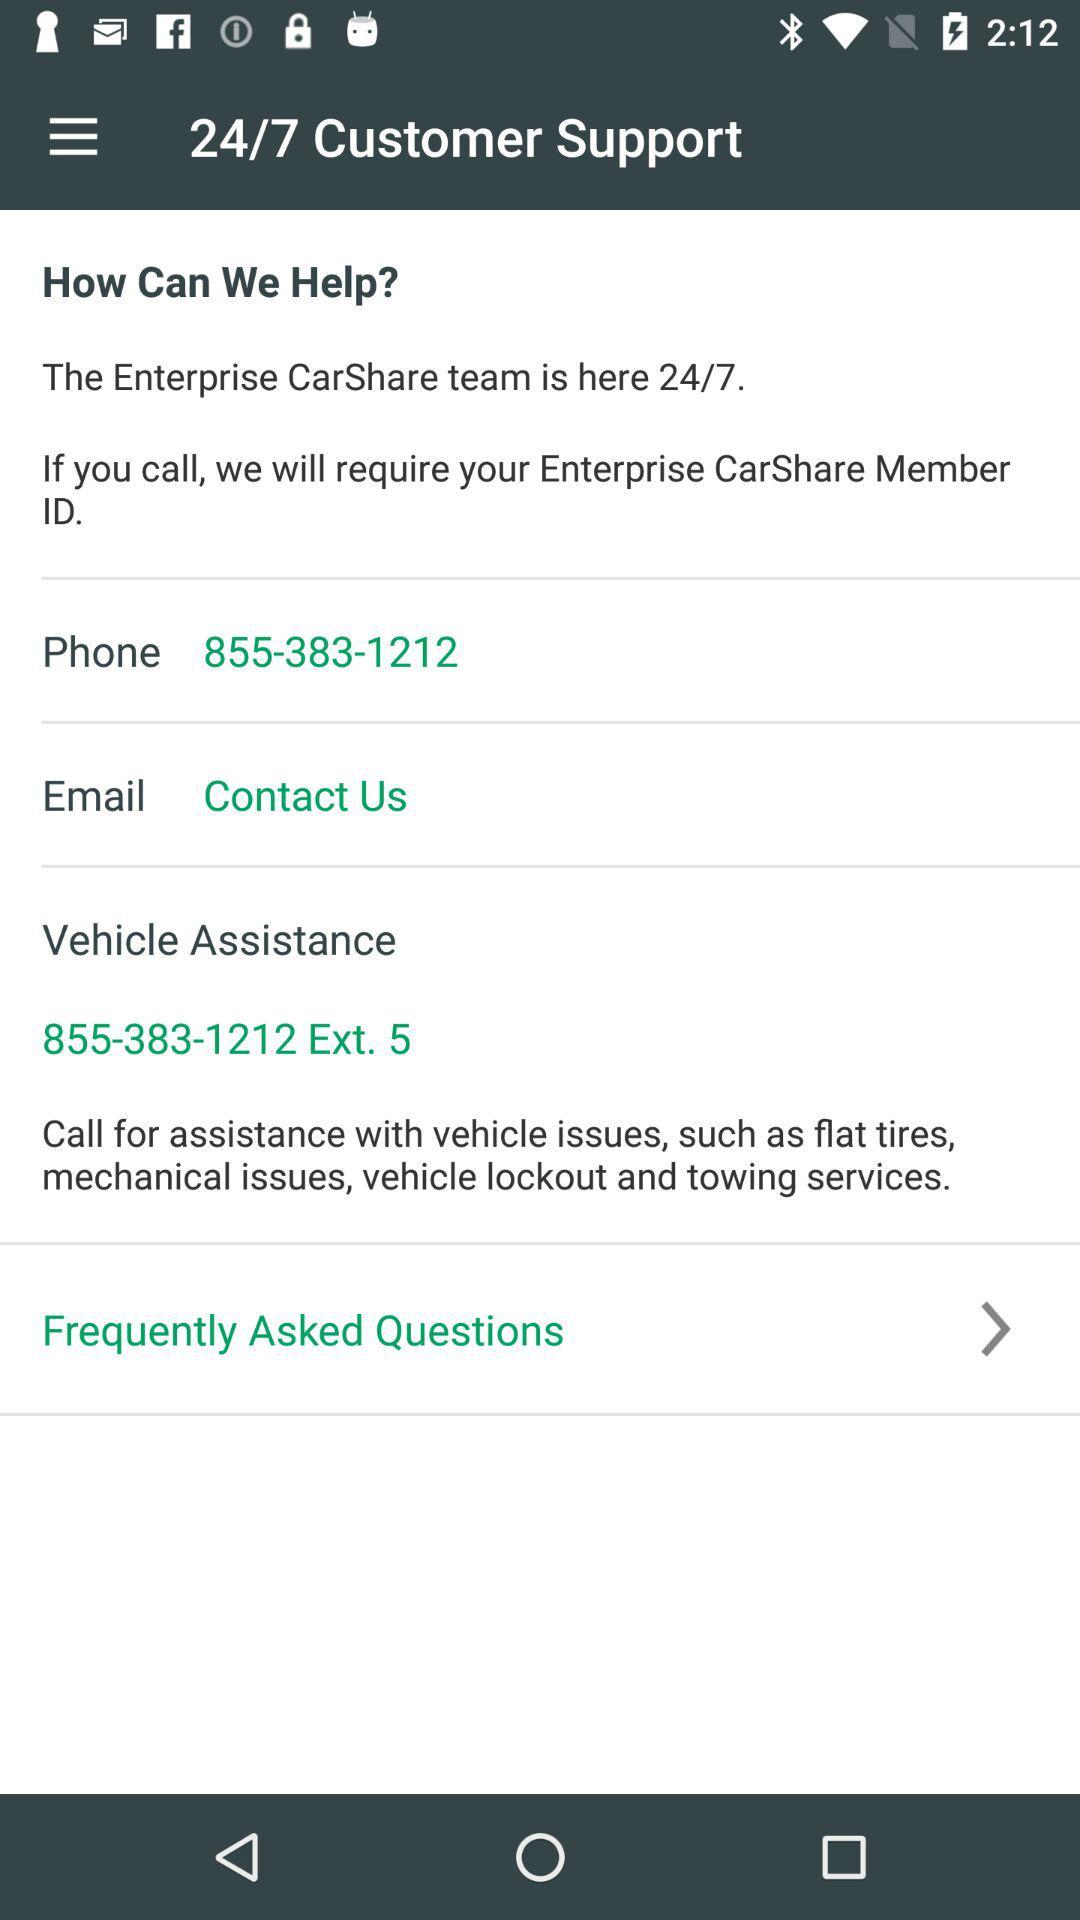What is the vehicle assistance number? The vehicle assistance number is 855-383-1212 Ext. 5. 